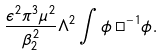<formula> <loc_0><loc_0><loc_500><loc_500>\frac { \epsilon ^ { 2 } \pi ^ { 3 } \mu ^ { 2 } } { \beta _ { 2 } ^ { 2 } } \Lambda ^ { 2 } \int \phi \, \Box ^ { - 1 } \phi .</formula> 